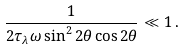<formula> <loc_0><loc_0><loc_500><loc_500>\frac { 1 } { 2 \tau _ { \lambda } \omega \sin ^ { 2 } 2 \theta \cos 2 \theta } \ll 1 \, .</formula> 